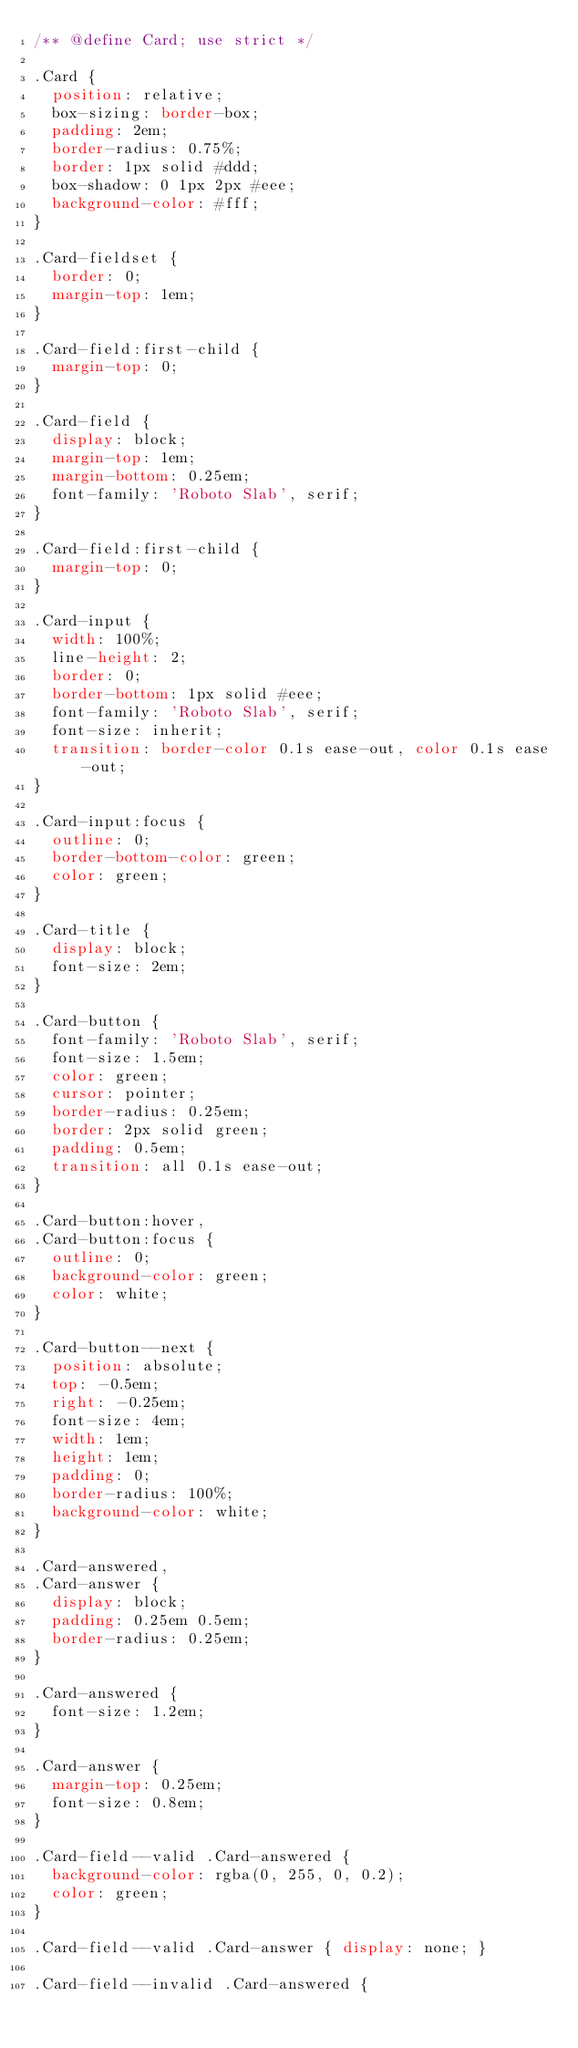Convert code to text. <code><loc_0><loc_0><loc_500><loc_500><_CSS_>/** @define Card; use strict */

.Card {
  position: relative;
  box-sizing: border-box;
  padding: 2em;
  border-radius: 0.75%;
  border: 1px solid #ddd;
  box-shadow: 0 1px 2px #eee;
  background-color: #fff;
}

.Card-fieldset {
  border: 0;
  margin-top: 1em;
}

.Card-field:first-child {
  margin-top: 0;
}

.Card-field {
  display: block;
  margin-top: 1em;
  margin-bottom: 0.25em;
  font-family: 'Roboto Slab', serif;
}

.Card-field:first-child {
  margin-top: 0;
}

.Card-input {  
  width: 100%;
  line-height: 2;
  border: 0;
  border-bottom: 1px solid #eee;
  font-family: 'Roboto Slab', serif;
  font-size: inherit;
  transition: border-color 0.1s ease-out, color 0.1s ease-out;
}

.Card-input:focus {
  outline: 0;
  border-bottom-color: green;
  color: green;
}

.Card-title {
  display: block;
  font-size: 2em;
}

.Card-button {
  font-family: 'Roboto Slab', serif;
  font-size: 1.5em;
  color: green;
  cursor: pointer;
  border-radius: 0.25em;
  border: 2px solid green;
  padding: 0.5em;
  transition: all 0.1s ease-out;
}

.Card-button:hover,
.Card-button:focus {
  outline: 0;
  background-color: green;
  color: white;
}

.Card-button--next {
  position: absolute;
  top: -0.5em;
  right: -0.25em;
  font-size: 4em;
  width: 1em;
  height: 1em;
  padding: 0;
  border-radius: 100%;
  background-color: white;
}

.Card-answered,
.Card-answer {
  display: block;
  padding: 0.25em 0.5em;
  border-radius: 0.25em;
}

.Card-answered {
  font-size: 1.2em;
}

.Card-answer {
  margin-top: 0.25em;
  font-size: 0.8em;
}

.Card-field--valid .Card-answered {
  background-color: rgba(0, 255, 0, 0.2);
  color: green;
}

.Card-field--valid .Card-answer { display: none; }

.Card-field--invalid .Card-answered {</code> 